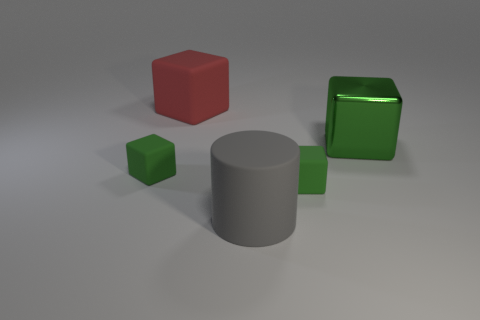What number of objects are left of the metal block and behind the gray thing?
Keep it short and to the point. 3. There is a large shiny thing; is its shape the same as the large matte thing that is behind the large green cube?
Your response must be concise. Yes. Are there more tiny green cubes on the right side of the gray cylinder than tiny red blocks?
Your answer should be compact. Yes. Is the number of large red rubber things that are in front of the rubber cylinder less than the number of shiny cubes?
Offer a terse response. Yes. What number of other blocks are the same color as the big shiny block?
Your answer should be very brief. 2. There is a big thing that is both in front of the red block and behind the cylinder; what is its material?
Provide a short and direct response. Metal. Is the color of the big cube in front of the large red block the same as the tiny rubber thing that is right of the red object?
Keep it short and to the point. Yes. What number of red objects are either big cubes or shiny cubes?
Your answer should be compact. 1. Are there fewer large red rubber things in front of the gray rubber thing than cubes that are behind the shiny thing?
Your answer should be compact. Yes. Are there any brown matte objects of the same size as the red thing?
Your response must be concise. No. 